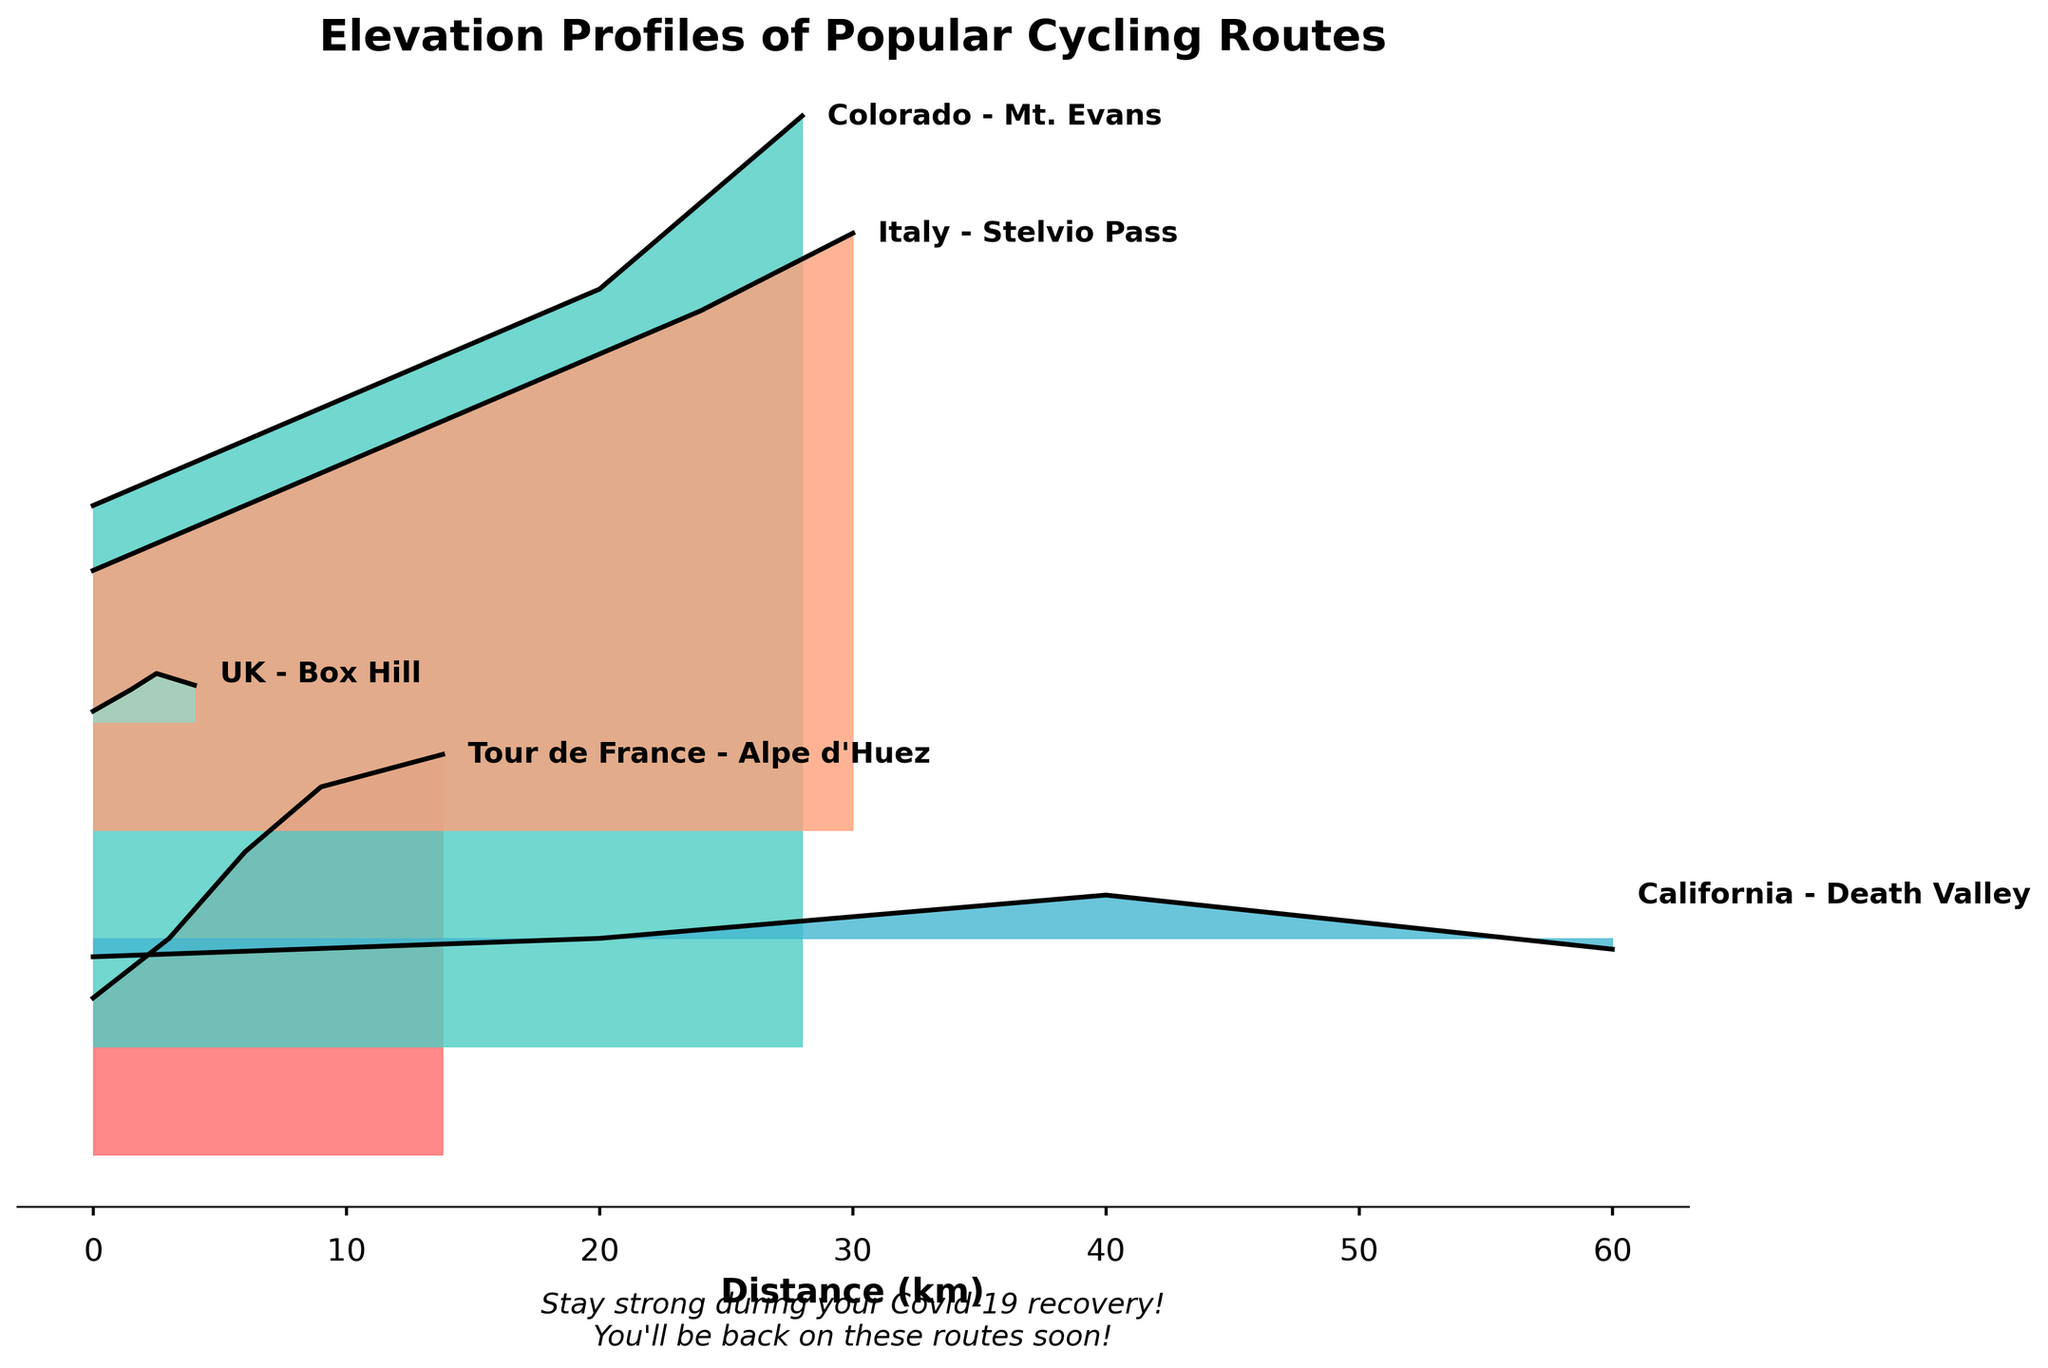what is the title of the figure? The title of the figure is displayed at the top and usually in bold. In this figure, the title is "Elevation Profiles of Popular Cycling Routes".
Answer: Elevation Profiles of Popular Cycling Routes How many regions are compared in the figure? Each region is represented by a separate ridgeline profile. By counting the ridgelines, we can see that there are five regions being compared.
Answer: Five Which cycling route has the highest peak elevation? To find the highest peak, we look for the ridgeline plot that reaches the highest elevation. The “Colorado - Mt. Evans” reaches the highest elevation at 4300 m.
Answer: Colorado - Mt. Evans Which route has the lowest starting elevation? The starting elevation can be identified at the leftmost point of each ridgeline. The “California - Death Valley” starts at -85 meters, which is the lowest.
Answer: California - Death Valley How does the elevation of the Tour de France - Alpe d'Huez change from the start to the end? By observing the plot for the Tour de France - Alpe d'Huez, we see it starts at 725 m, ascends progressively, and ends at 1850 m. The elevation increases from start to finish with multiple increments.
Answer: It increases How does the elevation profile of the UK - Box Hill differ from that of the Italy - Stelvio Pass? By comparing the elevation profiles, UK - Box Hill has a gentler and shorter climb, with just minor variations whereas Italy - Stelvio Pass has a longer and steeper climb, ending at a much higher elevation.
Answer: Shorter and gentler in the UK - Box Hill Which routes have a descent before the final ascent? By looking closely, we can see ridgeline plots that show a downward slope followed by an ascent. Tour de France - Alpe d'Huez and California - Death Valley show such patterns where elevation decreases before increasing again.
Answer: Tour de France - Alpe d’Huez and California - Death Valley At what approximate distance does the elevation of Colorado - Mt. Evans reach its peak? To determine when the elevation peaks, we identify the highest point on the ridgeline of Colorado - Mt. Evans and note the corresponding distance. It peaks at around 28 km.
Answer: 28 km What are the respective start and end elevations for the Italy - Stelvio Pass route? By tracing the start and end points of the Italy - Stelvio Pass route on the figure, we note the elevations at 0 km and 30 km. It starts at 1200 m and ends at 2758 m.
Answer: 1200 m and 2758 m 